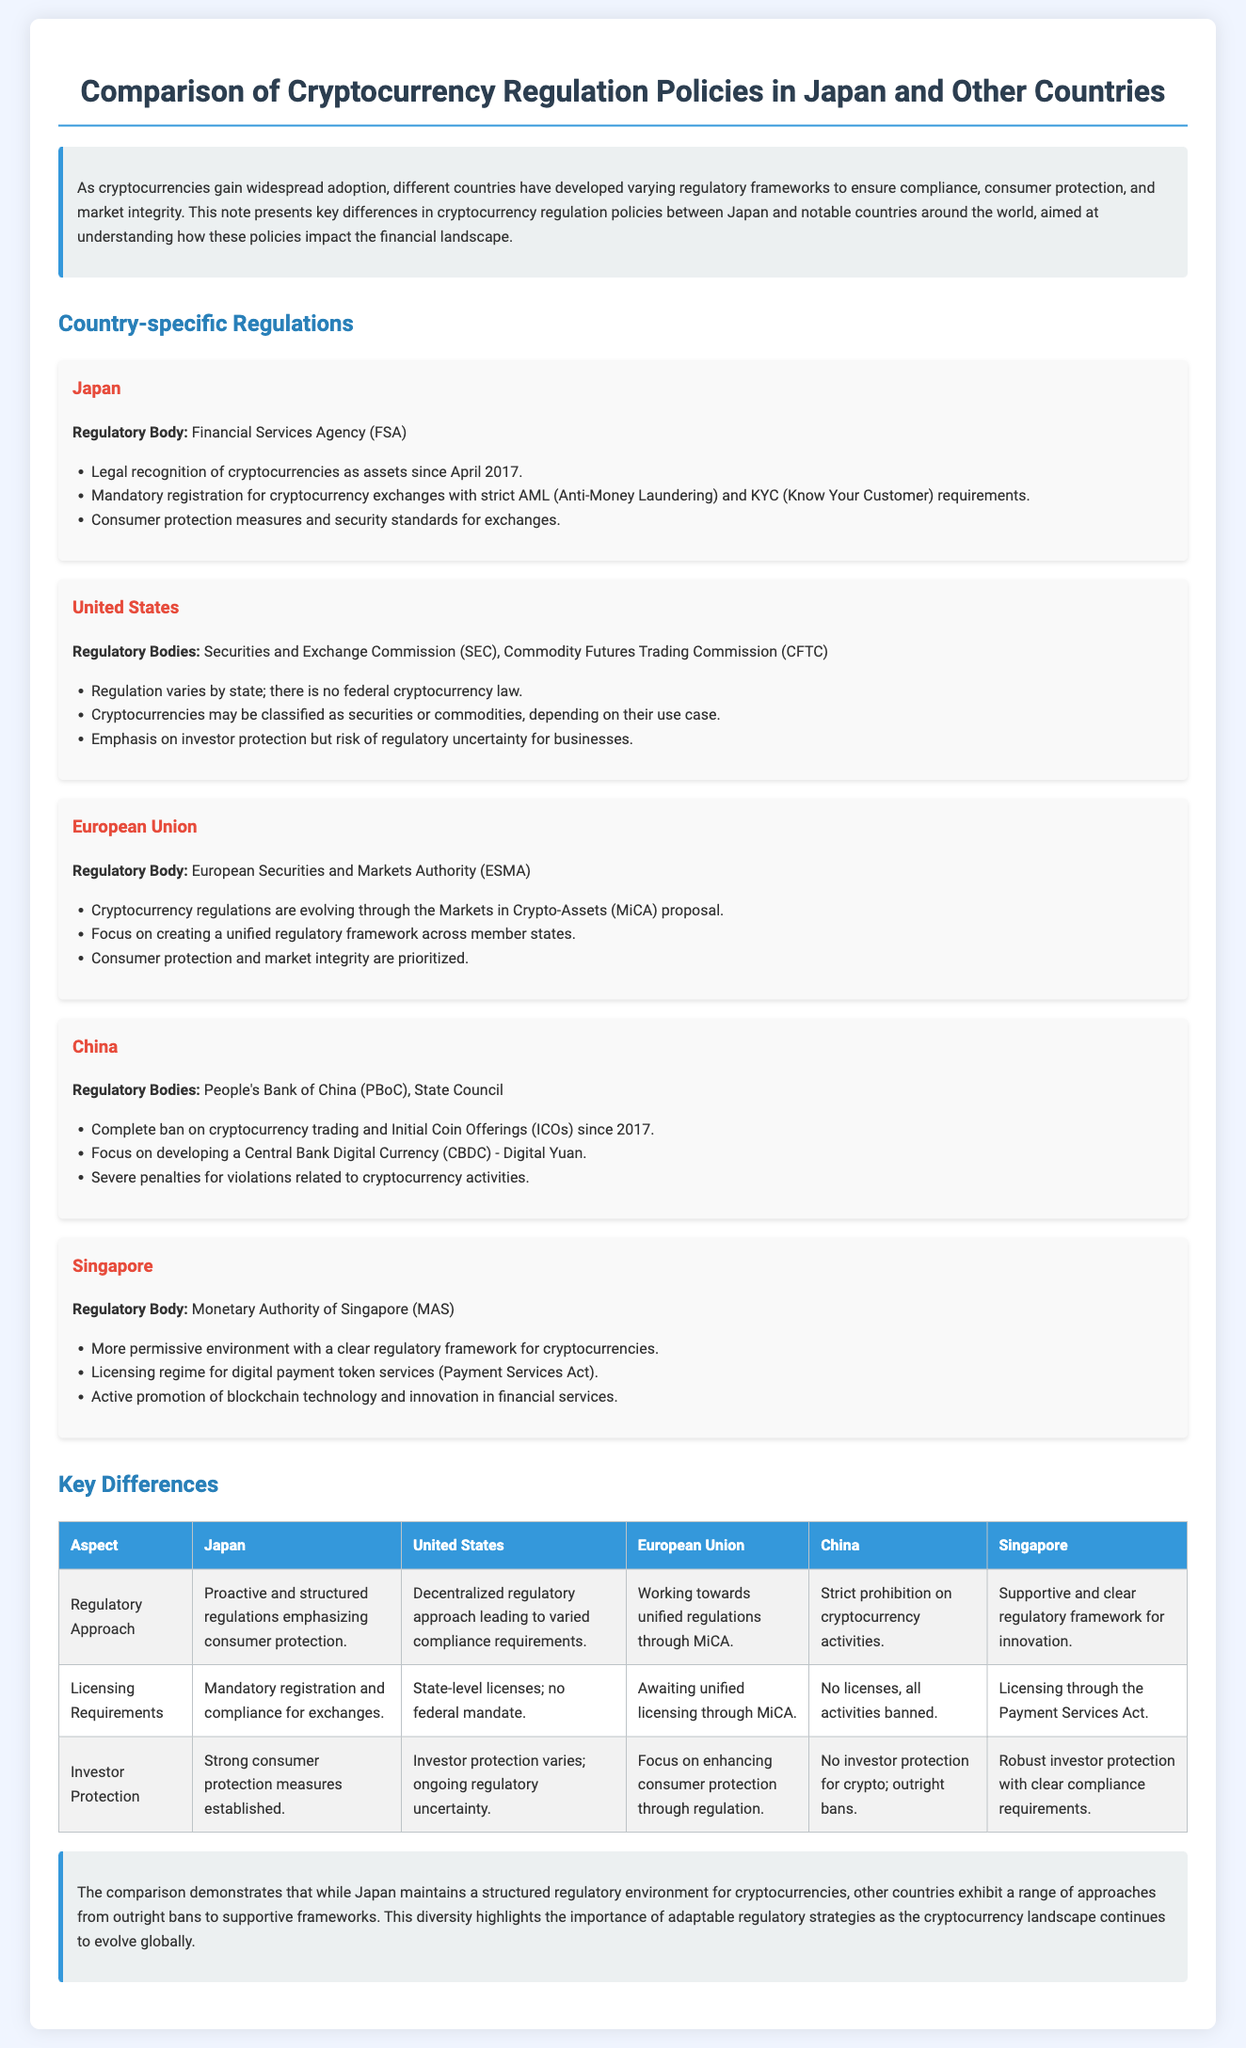What is the regulatory body in Japan? The regulatory body in Japan is the Financial Services Agency (FSA).
Answer: Financial Services Agency (FSA) What significant action was taken by China regarding cryptocurrency in 2017? China implemented a complete ban on cryptocurrency trading and Initial Coin Offerings (ICOs) in 2017.
Answer: Complete ban What is the focus of the European Union's cryptocurrency regulation efforts? The focus of the European Union's cryptocurrency regulation efforts is on creating a unified regulatory framework through the Markets in Crypto-Assets proposal.
Answer: Unified regulatory framework What type of environment does Singapore provide for cryptocurrency regulation? Singapore provides a more permissive environment with a clear regulatory framework for cryptocurrencies.
Answer: Permissive Which country operates with a decentralized regulatory approach? The United States operates with a decentralized regulatory approach leading to varied compliance requirements.
Answer: United States What is the aspect of investor protection in Japan's cryptocurrency regulation? Japan emphasizes strong consumer protection measures established within its regulatory framework.
Answer: Strong consumer protection How does Japan's regulatory approach compare to China's regarding cryptocurrency? Japan's regulatory approach is proactive and structured, while China's is a strict prohibition on cryptocurrency activities.
Answer: Proactive vs. prohibition What legislative act does Singapore use for licensing digital payment token services? Singapore uses the Payment Services Act for licensing digital payment token services.
Answer: Payment Services Act 